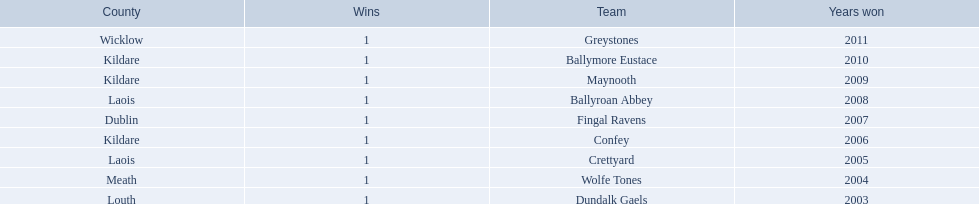What county is ballymore eustace from? Kildare. Besides convey, which other team is from the same county? Maynooth. 